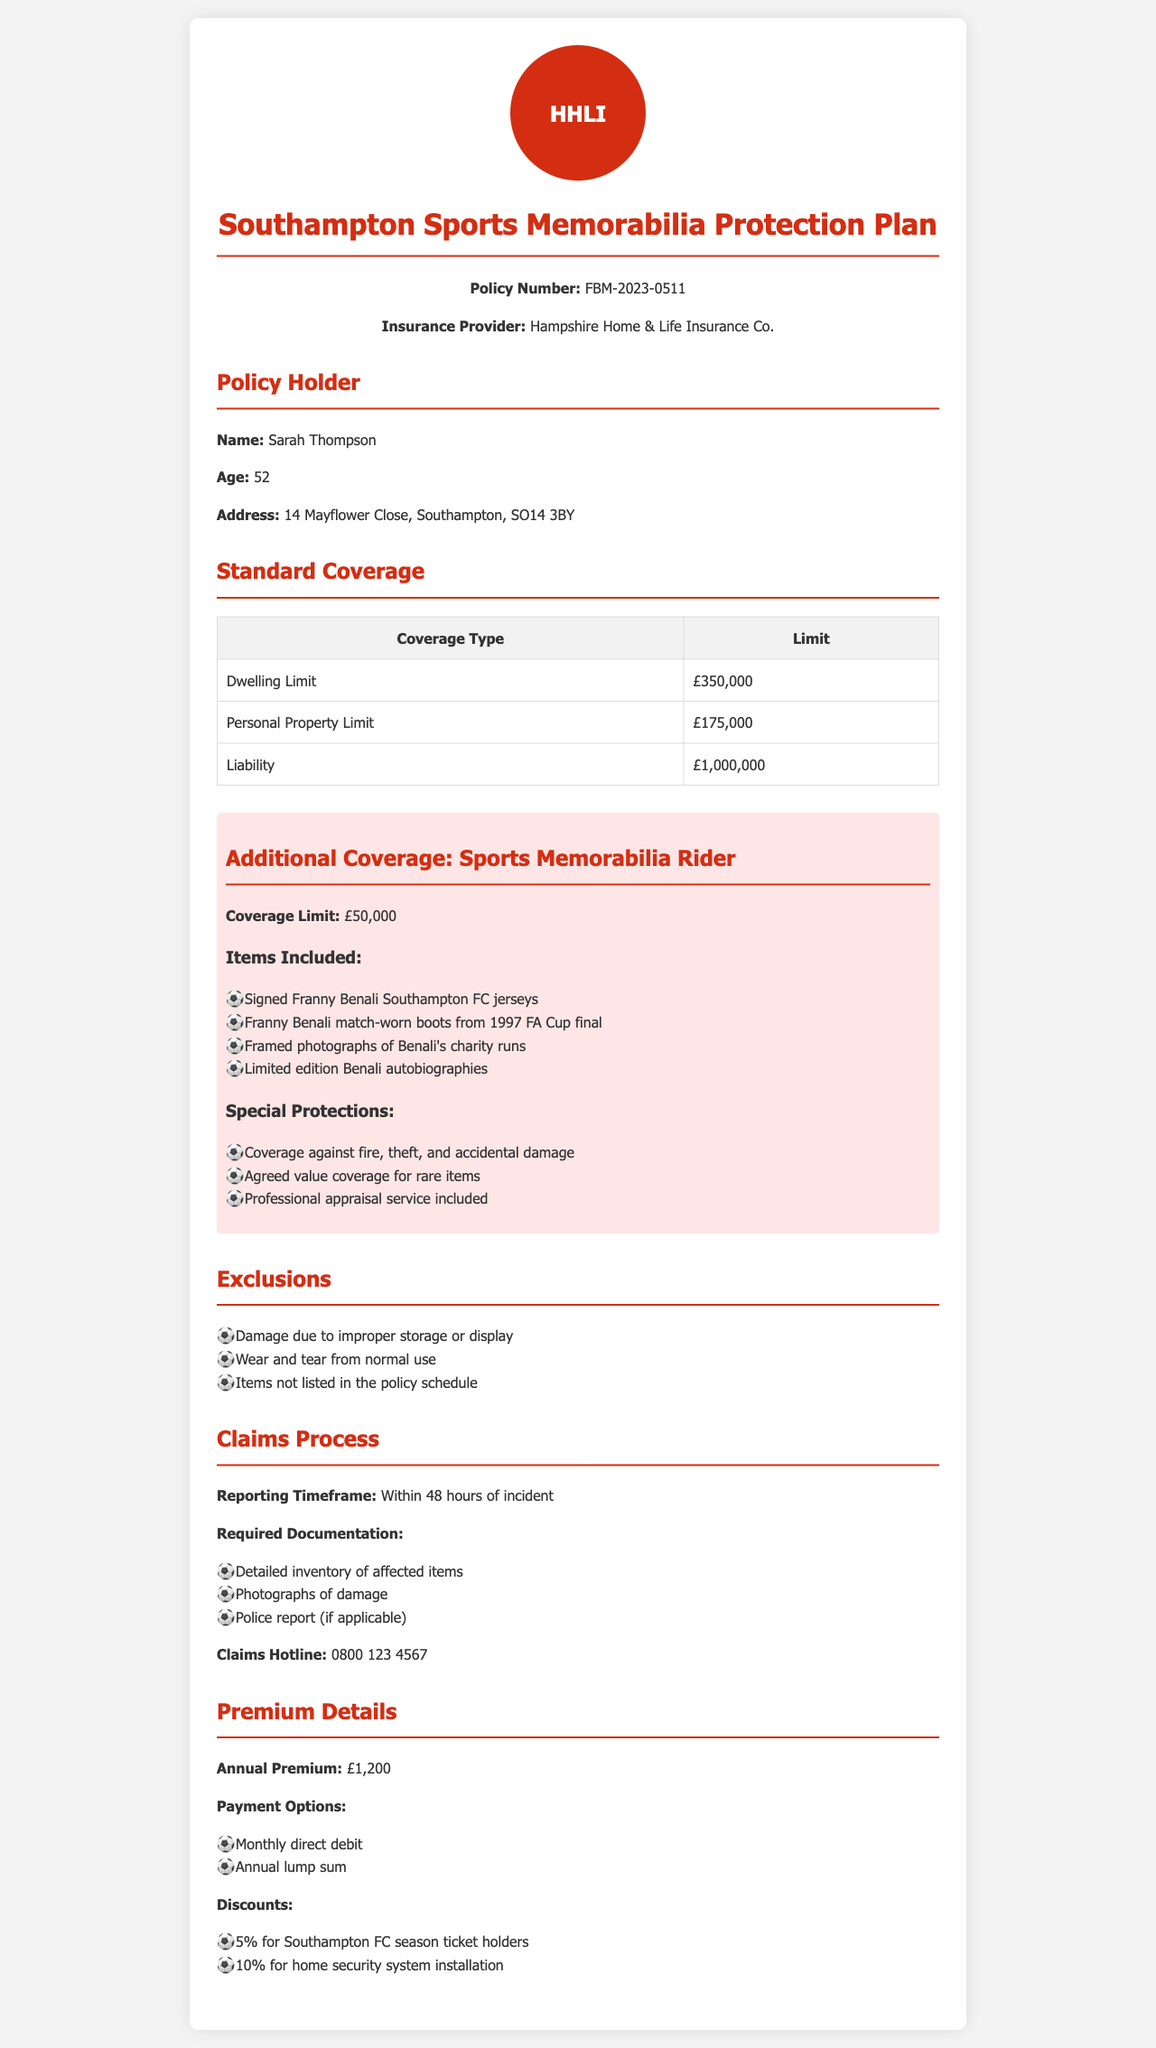What is the policy number? The policy number is listed at the top of the document under the title which reads FBM-2023-0511.
Answer: FBM-2023-0511 Who is the policy holder? The name of the policy holder is mentioned in the section titled "Policy Holder."
Answer: Sarah Thompson What is the coverage limit for sports memorabilia? The coverage limit for sports memorabilia is specified under the "Additional Coverage: Sports Memorabilia Rider" section.
Answer: £50,000 What types of special protections are included? The document lists the special protections in the "Additional Coverage" section regarding sports memorabilia.
Answer: Coverage against fire, theft, and accidental damage; Agreed value coverage for rare items; Professional appraisal service included What is the annual premium amount? The annual premium is stated in the "Premium Details" section of the document.
Answer: £1,200 What discounts are available for Southampton FC season ticket holders? The discounts are mentioned in the "Discounts" subsection under "Premium Details."
Answer: 5% What is the required documentation for claims? The required documentation is specified in the "Claims Process" section of the document.
Answer: Detailed inventory of affected items; Photographs of damage; Police report (if applicable) What are the exclusions for the sports memorabilia coverage? The exclusions for the sports memorabilia coverage are listed in the "Exclusions" section of the document.
Answer: Damage due to improper storage or display; Wear and tear from normal use; Items not listed in the policy schedule What is the claims reporting timeframe? The document provides the reporting timeframe in the "Claims Process" section.
Answer: Within 48 hours of incident 